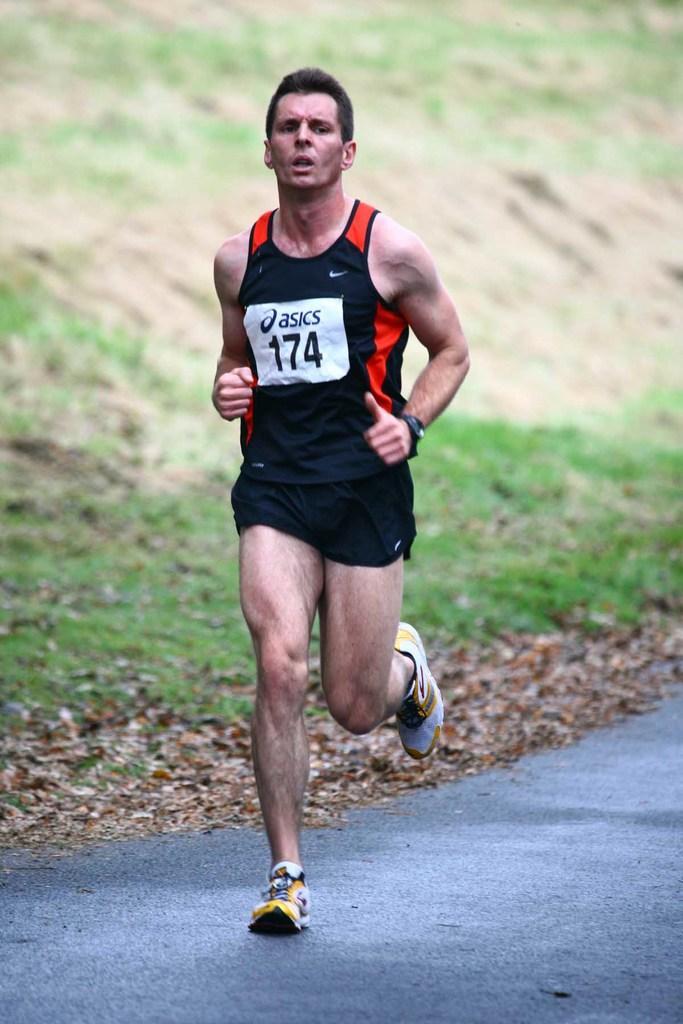Please provide a concise description of this image. In this image there is a boy running on the road. There is a number badge to his shirt. In the background there is grass. On the ground there are dry leaves. 